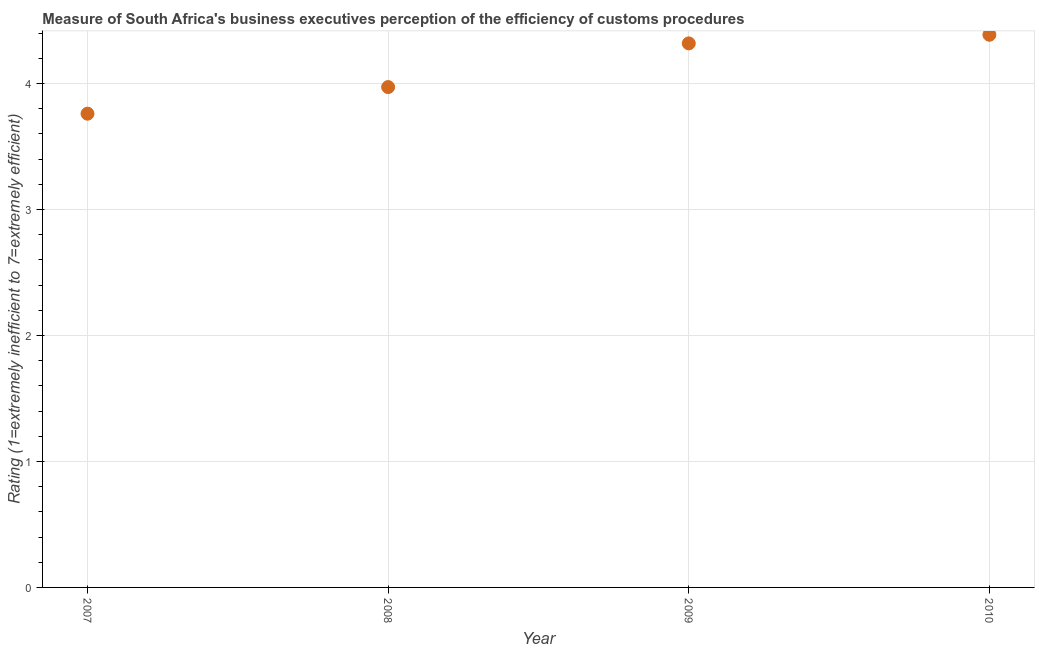What is the rating measuring burden of customs procedure in 2010?
Provide a short and direct response. 4.39. Across all years, what is the maximum rating measuring burden of customs procedure?
Provide a short and direct response. 4.39. Across all years, what is the minimum rating measuring burden of customs procedure?
Your response must be concise. 3.76. In which year was the rating measuring burden of customs procedure minimum?
Make the answer very short. 2007. What is the sum of the rating measuring burden of customs procedure?
Provide a short and direct response. 16.44. What is the difference between the rating measuring burden of customs procedure in 2007 and 2010?
Provide a short and direct response. -0.63. What is the average rating measuring burden of customs procedure per year?
Your answer should be very brief. 4.11. What is the median rating measuring burden of customs procedure?
Your answer should be very brief. 4.14. Do a majority of the years between 2009 and 2007 (inclusive) have rating measuring burden of customs procedure greater than 0.4 ?
Your answer should be compact. No. What is the ratio of the rating measuring burden of customs procedure in 2007 to that in 2008?
Provide a short and direct response. 0.95. Is the difference between the rating measuring burden of customs procedure in 2007 and 2008 greater than the difference between any two years?
Your answer should be compact. No. What is the difference between the highest and the second highest rating measuring burden of customs procedure?
Your response must be concise. 0.07. What is the difference between the highest and the lowest rating measuring burden of customs procedure?
Provide a succinct answer. 0.63. What is the difference between two consecutive major ticks on the Y-axis?
Offer a very short reply. 1. Are the values on the major ticks of Y-axis written in scientific E-notation?
Provide a short and direct response. No. Does the graph contain grids?
Keep it short and to the point. Yes. What is the title of the graph?
Your response must be concise. Measure of South Africa's business executives perception of the efficiency of customs procedures. What is the label or title of the X-axis?
Provide a short and direct response. Year. What is the label or title of the Y-axis?
Make the answer very short. Rating (1=extremely inefficient to 7=extremely efficient). What is the Rating (1=extremely inefficient to 7=extremely efficient) in 2007?
Give a very brief answer. 3.76. What is the Rating (1=extremely inefficient to 7=extremely efficient) in 2008?
Offer a terse response. 3.97. What is the Rating (1=extremely inefficient to 7=extremely efficient) in 2009?
Keep it short and to the point. 4.32. What is the Rating (1=extremely inefficient to 7=extremely efficient) in 2010?
Your answer should be compact. 4.39. What is the difference between the Rating (1=extremely inefficient to 7=extremely efficient) in 2007 and 2008?
Your answer should be very brief. -0.21. What is the difference between the Rating (1=extremely inefficient to 7=extremely efficient) in 2007 and 2009?
Ensure brevity in your answer.  -0.56. What is the difference between the Rating (1=extremely inefficient to 7=extremely efficient) in 2007 and 2010?
Your answer should be compact. -0.63. What is the difference between the Rating (1=extremely inefficient to 7=extremely efficient) in 2008 and 2009?
Provide a short and direct response. -0.35. What is the difference between the Rating (1=extremely inefficient to 7=extremely efficient) in 2008 and 2010?
Give a very brief answer. -0.42. What is the difference between the Rating (1=extremely inefficient to 7=extremely efficient) in 2009 and 2010?
Your answer should be very brief. -0.07. What is the ratio of the Rating (1=extremely inefficient to 7=extremely efficient) in 2007 to that in 2008?
Offer a very short reply. 0.95. What is the ratio of the Rating (1=extremely inefficient to 7=extremely efficient) in 2007 to that in 2009?
Make the answer very short. 0.87. What is the ratio of the Rating (1=extremely inefficient to 7=extremely efficient) in 2007 to that in 2010?
Your answer should be very brief. 0.86. What is the ratio of the Rating (1=extremely inefficient to 7=extremely efficient) in 2008 to that in 2010?
Make the answer very short. 0.91. What is the ratio of the Rating (1=extremely inefficient to 7=extremely efficient) in 2009 to that in 2010?
Your response must be concise. 0.98. 